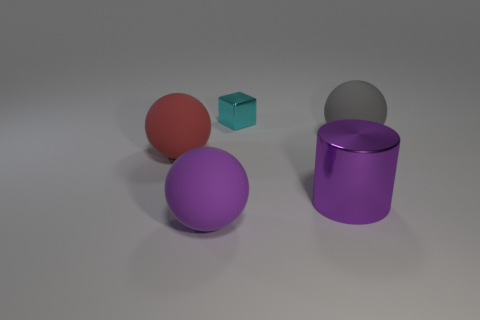Add 4 red metallic blocks. How many objects exist? 9 Subtract all big purple matte balls. How many balls are left? 2 Add 2 large purple rubber spheres. How many large purple rubber spheres are left? 3 Add 5 gray balls. How many gray balls exist? 6 Subtract all purple spheres. How many spheres are left? 2 Subtract 1 purple cylinders. How many objects are left? 4 Subtract all balls. How many objects are left? 2 Subtract 1 cylinders. How many cylinders are left? 0 Subtract all blue cylinders. Subtract all purple blocks. How many cylinders are left? 1 Subtract all blue cylinders. How many brown cubes are left? 0 